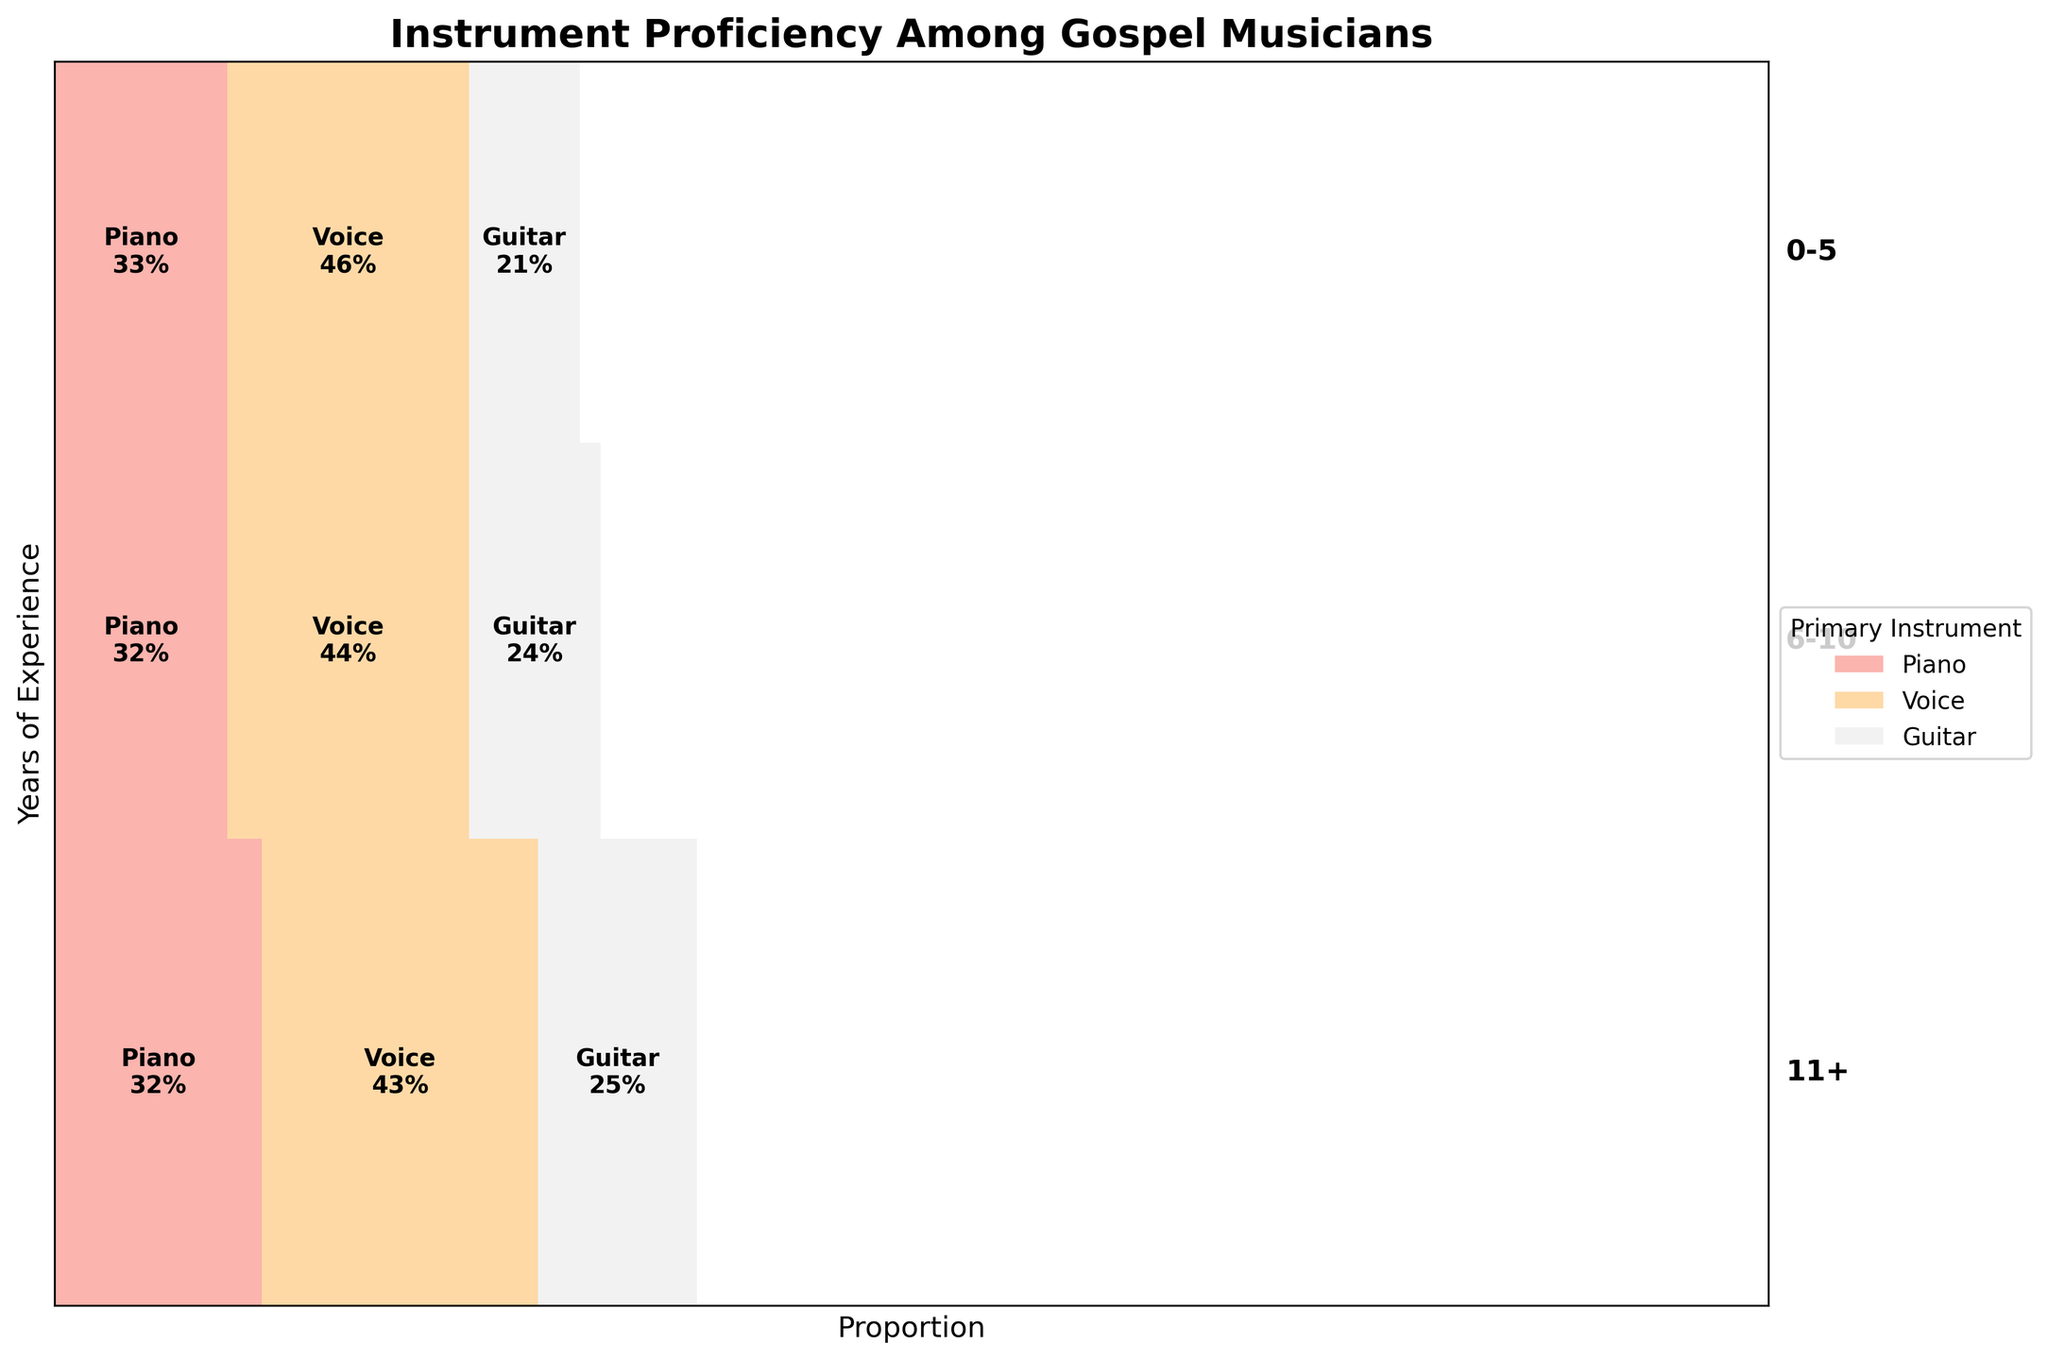What are the main categories represented in the plot? The main categories represented in the plot are Years of Experience, Primary Instrument, and Proficiency Level. These form the axes and segments of the mosaic plot.
Answer: Years of Experience, Primary Instrument, Proficiency Level Which primary instrument has the largest section for the 0-5 years experience group? The section sizes represent the proportion of each instrument within the experience group. For the 0-5 years experience group, the largest section belongs to the "Voice" instrument.
Answer: Voice How does the proficiency level distribution change for the piano from the 0-5 years group to the 11+ years group? For the 0-5 years group, the proportions are more skewed towards Beginner and Intermediate proficiency levels. For the 11+ years group, the distribution shifts significantly towards the Advanced proficiency level, indicating increased skill with more experience.
Answer: Shifts from Beginner/Intermediate to Advanced Which instrument and experience group combinations have no Advanced proficiency level representation? By checking the shaded areas for the smallest divisions representing Advanced proficiency, it is visible that the 0-5 years Guitar group has negligible or no Advanced representation.
Answer: 0-5 years, Guitar What is the total combined proportion of Intermediate and Advanced proficiency levels for voice musicians with 6-10 years of experience? To find the combined proportion, sum the segments for Intermediate and Advanced voice musicians within the 6-10 years group. These segments represent a large part of the total for this experience group.
Answer: A large combined segment How does the distribution of Guitar proficiency levels compare across the different experience groups? In the 0-5 years group, Guitar shows a majority in the Beginner level. With 6-10 years, the distribution becomes more balanced, and further shifts towards Intermediate and Advanced levels in the 11+ years group.
Answer: Shifts from Beginner to balance to more Advanced Which group has the highest proportion of Advanced proficiency level among musicians? By comparing the heights of the rectangles representing Advanced proficiency levels, the 11+ years experience Voice instrument group has the highest proportion.
Answer: 11+ years, Voice How does the proportion of Intermediate proficiency level for piano musicians change as experience increases? For piano musicians, initially, the proportion of Intermediate level is small in the 0-5 years group but grows in the 6-10 years group and finally stabilizes in the 11+ years group.
Answer: Increases initially, then stabilizes What instrument has the smallest proportion of Intermediate proficiency across all experience groups? By comparing the Intermediate sections for each instrument across experience groups, Guitar generally has the smallest Intermediate proportions.
Answer: Guitar Which experience group shows the most evenly distributed proficiency levels for the Voice instrument? The 6-10 years group for Voice shows a more balanced distribution across Beginner, Intermediate, and Advanced proficiency levels compared to other experience groups.
Answer: 6-10 years 